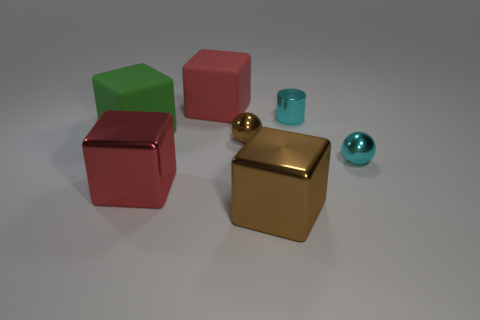Add 1 large green things. How many objects exist? 8 Subtract all green cubes. How many cubes are left? 3 Subtract all red metallic blocks. How many blocks are left? 3 Add 3 small yellow metal cubes. How many small yellow metal cubes exist? 3 Subtract 0 red balls. How many objects are left? 7 Subtract all balls. How many objects are left? 5 Subtract 1 cubes. How many cubes are left? 3 Subtract all red cubes. Subtract all brown spheres. How many cubes are left? 2 Subtract all gray blocks. How many brown spheres are left? 1 Subtract all large blue matte objects. Subtract all small shiny things. How many objects are left? 4 